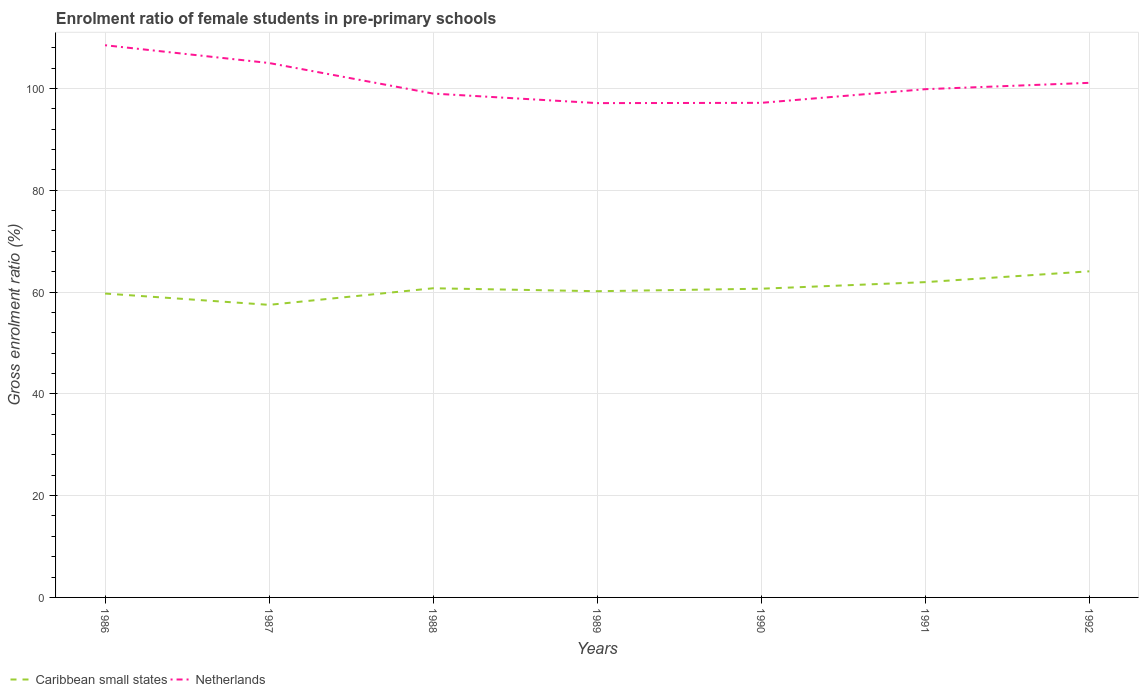How many different coloured lines are there?
Give a very brief answer. 2. Is the number of lines equal to the number of legend labels?
Your answer should be compact. Yes. Across all years, what is the maximum enrolment ratio of female students in pre-primary schools in Netherlands?
Make the answer very short. 97.11. In which year was the enrolment ratio of female students in pre-primary schools in Netherlands maximum?
Offer a very short reply. 1989. What is the total enrolment ratio of female students in pre-primary schools in Netherlands in the graph?
Make the answer very short. 6. What is the difference between the highest and the second highest enrolment ratio of female students in pre-primary schools in Caribbean small states?
Provide a short and direct response. 6.59. What is the difference between the highest and the lowest enrolment ratio of female students in pre-primary schools in Caribbean small states?
Ensure brevity in your answer.  3. Is the enrolment ratio of female students in pre-primary schools in Netherlands strictly greater than the enrolment ratio of female students in pre-primary schools in Caribbean small states over the years?
Make the answer very short. No. How many lines are there?
Provide a succinct answer. 2. How are the legend labels stacked?
Keep it short and to the point. Horizontal. What is the title of the graph?
Ensure brevity in your answer.  Enrolment ratio of female students in pre-primary schools. Does "Uzbekistan" appear as one of the legend labels in the graph?
Offer a terse response. No. What is the label or title of the X-axis?
Offer a very short reply. Years. What is the label or title of the Y-axis?
Your answer should be very brief. Gross enrolment ratio (%). What is the Gross enrolment ratio (%) in Caribbean small states in 1986?
Provide a short and direct response. 59.7. What is the Gross enrolment ratio (%) in Netherlands in 1986?
Offer a very short reply. 108.48. What is the Gross enrolment ratio (%) of Caribbean small states in 1987?
Your answer should be very brief. 57.48. What is the Gross enrolment ratio (%) of Netherlands in 1987?
Offer a very short reply. 104.98. What is the Gross enrolment ratio (%) in Caribbean small states in 1988?
Provide a short and direct response. 60.73. What is the Gross enrolment ratio (%) of Netherlands in 1988?
Your response must be concise. 98.98. What is the Gross enrolment ratio (%) in Caribbean small states in 1989?
Give a very brief answer. 60.16. What is the Gross enrolment ratio (%) in Netherlands in 1989?
Make the answer very short. 97.11. What is the Gross enrolment ratio (%) of Caribbean small states in 1990?
Your answer should be compact. 60.65. What is the Gross enrolment ratio (%) in Netherlands in 1990?
Your answer should be compact. 97.16. What is the Gross enrolment ratio (%) in Caribbean small states in 1991?
Keep it short and to the point. 61.94. What is the Gross enrolment ratio (%) of Netherlands in 1991?
Provide a short and direct response. 99.84. What is the Gross enrolment ratio (%) of Caribbean small states in 1992?
Offer a very short reply. 64.06. What is the Gross enrolment ratio (%) of Netherlands in 1992?
Your response must be concise. 101.09. Across all years, what is the maximum Gross enrolment ratio (%) in Caribbean small states?
Your answer should be compact. 64.06. Across all years, what is the maximum Gross enrolment ratio (%) of Netherlands?
Make the answer very short. 108.48. Across all years, what is the minimum Gross enrolment ratio (%) of Caribbean small states?
Your answer should be very brief. 57.48. Across all years, what is the minimum Gross enrolment ratio (%) in Netherlands?
Ensure brevity in your answer.  97.11. What is the total Gross enrolment ratio (%) of Caribbean small states in the graph?
Offer a very short reply. 424.71. What is the total Gross enrolment ratio (%) of Netherlands in the graph?
Provide a short and direct response. 707.64. What is the difference between the Gross enrolment ratio (%) in Caribbean small states in 1986 and that in 1987?
Provide a succinct answer. 2.22. What is the difference between the Gross enrolment ratio (%) in Netherlands in 1986 and that in 1987?
Make the answer very short. 3.49. What is the difference between the Gross enrolment ratio (%) of Caribbean small states in 1986 and that in 1988?
Give a very brief answer. -1.04. What is the difference between the Gross enrolment ratio (%) of Netherlands in 1986 and that in 1988?
Provide a succinct answer. 9.5. What is the difference between the Gross enrolment ratio (%) in Caribbean small states in 1986 and that in 1989?
Keep it short and to the point. -0.46. What is the difference between the Gross enrolment ratio (%) in Netherlands in 1986 and that in 1989?
Ensure brevity in your answer.  11.37. What is the difference between the Gross enrolment ratio (%) of Caribbean small states in 1986 and that in 1990?
Give a very brief answer. -0.95. What is the difference between the Gross enrolment ratio (%) in Netherlands in 1986 and that in 1990?
Offer a very short reply. 11.32. What is the difference between the Gross enrolment ratio (%) of Caribbean small states in 1986 and that in 1991?
Your response must be concise. -2.24. What is the difference between the Gross enrolment ratio (%) in Netherlands in 1986 and that in 1991?
Make the answer very short. 8.63. What is the difference between the Gross enrolment ratio (%) in Caribbean small states in 1986 and that in 1992?
Your response must be concise. -4.37. What is the difference between the Gross enrolment ratio (%) in Netherlands in 1986 and that in 1992?
Provide a short and direct response. 7.39. What is the difference between the Gross enrolment ratio (%) in Caribbean small states in 1987 and that in 1988?
Provide a short and direct response. -3.26. What is the difference between the Gross enrolment ratio (%) of Netherlands in 1987 and that in 1988?
Provide a short and direct response. 6. What is the difference between the Gross enrolment ratio (%) of Caribbean small states in 1987 and that in 1989?
Ensure brevity in your answer.  -2.68. What is the difference between the Gross enrolment ratio (%) of Netherlands in 1987 and that in 1989?
Your response must be concise. 7.88. What is the difference between the Gross enrolment ratio (%) of Caribbean small states in 1987 and that in 1990?
Make the answer very short. -3.17. What is the difference between the Gross enrolment ratio (%) in Netherlands in 1987 and that in 1990?
Ensure brevity in your answer.  7.83. What is the difference between the Gross enrolment ratio (%) of Caribbean small states in 1987 and that in 1991?
Offer a very short reply. -4.46. What is the difference between the Gross enrolment ratio (%) of Netherlands in 1987 and that in 1991?
Your answer should be very brief. 5.14. What is the difference between the Gross enrolment ratio (%) of Caribbean small states in 1987 and that in 1992?
Keep it short and to the point. -6.59. What is the difference between the Gross enrolment ratio (%) in Netherlands in 1987 and that in 1992?
Offer a very short reply. 3.89. What is the difference between the Gross enrolment ratio (%) in Caribbean small states in 1988 and that in 1989?
Provide a succinct answer. 0.58. What is the difference between the Gross enrolment ratio (%) in Netherlands in 1988 and that in 1989?
Your response must be concise. 1.87. What is the difference between the Gross enrolment ratio (%) of Caribbean small states in 1988 and that in 1990?
Your response must be concise. 0.09. What is the difference between the Gross enrolment ratio (%) in Netherlands in 1988 and that in 1990?
Offer a terse response. 1.82. What is the difference between the Gross enrolment ratio (%) in Caribbean small states in 1988 and that in 1991?
Your response must be concise. -1.2. What is the difference between the Gross enrolment ratio (%) of Netherlands in 1988 and that in 1991?
Make the answer very short. -0.86. What is the difference between the Gross enrolment ratio (%) of Caribbean small states in 1988 and that in 1992?
Ensure brevity in your answer.  -3.33. What is the difference between the Gross enrolment ratio (%) in Netherlands in 1988 and that in 1992?
Your answer should be very brief. -2.11. What is the difference between the Gross enrolment ratio (%) in Caribbean small states in 1989 and that in 1990?
Offer a very short reply. -0.49. What is the difference between the Gross enrolment ratio (%) of Netherlands in 1989 and that in 1990?
Provide a succinct answer. -0.05. What is the difference between the Gross enrolment ratio (%) in Caribbean small states in 1989 and that in 1991?
Your answer should be very brief. -1.78. What is the difference between the Gross enrolment ratio (%) of Netherlands in 1989 and that in 1991?
Give a very brief answer. -2.74. What is the difference between the Gross enrolment ratio (%) in Caribbean small states in 1989 and that in 1992?
Your answer should be compact. -3.91. What is the difference between the Gross enrolment ratio (%) in Netherlands in 1989 and that in 1992?
Your response must be concise. -3.98. What is the difference between the Gross enrolment ratio (%) in Caribbean small states in 1990 and that in 1991?
Make the answer very short. -1.29. What is the difference between the Gross enrolment ratio (%) in Netherlands in 1990 and that in 1991?
Offer a very short reply. -2.69. What is the difference between the Gross enrolment ratio (%) in Caribbean small states in 1990 and that in 1992?
Make the answer very short. -3.42. What is the difference between the Gross enrolment ratio (%) in Netherlands in 1990 and that in 1992?
Give a very brief answer. -3.93. What is the difference between the Gross enrolment ratio (%) in Caribbean small states in 1991 and that in 1992?
Give a very brief answer. -2.13. What is the difference between the Gross enrolment ratio (%) in Netherlands in 1991 and that in 1992?
Make the answer very short. -1.25. What is the difference between the Gross enrolment ratio (%) in Caribbean small states in 1986 and the Gross enrolment ratio (%) in Netherlands in 1987?
Offer a very short reply. -45.28. What is the difference between the Gross enrolment ratio (%) in Caribbean small states in 1986 and the Gross enrolment ratio (%) in Netherlands in 1988?
Provide a short and direct response. -39.28. What is the difference between the Gross enrolment ratio (%) of Caribbean small states in 1986 and the Gross enrolment ratio (%) of Netherlands in 1989?
Provide a succinct answer. -37.41. What is the difference between the Gross enrolment ratio (%) of Caribbean small states in 1986 and the Gross enrolment ratio (%) of Netherlands in 1990?
Give a very brief answer. -37.46. What is the difference between the Gross enrolment ratio (%) of Caribbean small states in 1986 and the Gross enrolment ratio (%) of Netherlands in 1991?
Your answer should be very brief. -40.15. What is the difference between the Gross enrolment ratio (%) of Caribbean small states in 1986 and the Gross enrolment ratio (%) of Netherlands in 1992?
Keep it short and to the point. -41.39. What is the difference between the Gross enrolment ratio (%) of Caribbean small states in 1987 and the Gross enrolment ratio (%) of Netherlands in 1988?
Your answer should be compact. -41.5. What is the difference between the Gross enrolment ratio (%) in Caribbean small states in 1987 and the Gross enrolment ratio (%) in Netherlands in 1989?
Offer a very short reply. -39.63. What is the difference between the Gross enrolment ratio (%) in Caribbean small states in 1987 and the Gross enrolment ratio (%) in Netherlands in 1990?
Offer a very short reply. -39.68. What is the difference between the Gross enrolment ratio (%) in Caribbean small states in 1987 and the Gross enrolment ratio (%) in Netherlands in 1991?
Your response must be concise. -42.37. What is the difference between the Gross enrolment ratio (%) in Caribbean small states in 1987 and the Gross enrolment ratio (%) in Netherlands in 1992?
Provide a short and direct response. -43.61. What is the difference between the Gross enrolment ratio (%) of Caribbean small states in 1988 and the Gross enrolment ratio (%) of Netherlands in 1989?
Provide a short and direct response. -36.37. What is the difference between the Gross enrolment ratio (%) in Caribbean small states in 1988 and the Gross enrolment ratio (%) in Netherlands in 1990?
Keep it short and to the point. -36.42. What is the difference between the Gross enrolment ratio (%) of Caribbean small states in 1988 and the Gross enrolment ratio (%) of Netherlands in 1991?
Give a very brief answer. -39.11. What is the difference between the Gross enrolment ratio (%) of Caribbean small states in 1988 and the Gross enrolment ratio (%) of Netherlands in 1992?
Your answer should be compact. -40.35. What is the difference between the Gross enrolment ratio (%) in Caribbean small states in 1989 and the Gross enrolment ratio (%) in Netherlands in 1990?
Provide a short and direct response. -37. What is the difference between the Gross enrolment ratio (%) in Caribbean small states in 1989 and the Gross enrolment ratio (%) in Netherlands in 1991?
Your response must be concise. -39.69. What is the difference between the Gross enrolment ratio (%) of Caribbean small states in 1989 and the Gross enrolment ratio (%) of Netherlands in 1992?
Offer a very short reply. -40.93. What is the difference between the Gross enrolment ratio (%) of Caribbean small states in 1990 and the Gross enrolment ratio (%) of Netherlands in 1991?
Offer a terse response. -39.2. What is the difference between the Gross enrolment ratio (%) in Caribbean small states in 1990 and the Gross enrolment ratio (%) in Netherlands in 1992?
Your answer should be very brief. -40.44. What is the difference between the Gross enrolment ratio (%) in Caribbean small states in 1991 and the Gross enrolment ratio (%) in Netherlands in 1992?
Offer a terse response. -39.15. What is the average Gross enrolment ratio (%) in Caribbean small states per year?
Offer a terse response. 60.67. What is the average Gross enrolment ratio (%) in Netherlands per year?
Provide a short and direct response. 101.09. In the year 1986, what is the difference between the Gross enrolment ratio (%) of Caribbean small states and Gross enrolment ratio (%) of Netherlands?
Offer a very short reply. -48.78. In the year 1987, what is the difference between the Gross enrolment ratio (%) in Caribbean small states and Gross enrolment ratio (%) in Netherlands?
Give a very brief answer. -47.51. In the year 1988, what is the difference between the Gross enrolment ratio (%) of Caribbean small states and Gross enrolment ratio (%) of Netherlands?
Offer a terse response. -38.25. In the year 1989, what is the difference between the Gross enrolment ratio (%) in Caribbean small states and Gross enrolment ratio (%) in Netherlands?
Offer a terse response. -36.95. In the year 1990, what is the difference between the Gross enrolment ratio (%) of Caribbean small states and Gross enrolment ratio (%) of Netherlands?
Your response must be concise. -36.51. In the year 1991, what is the difference between the Gross enrolment ratio (%) of Caribbean small states and Gross enrolment ratio (%) of Netherlands?
Offer a very short reply. -37.91. In the year 1992, what is the difference between the Gross enrolment ratio (%) of Caribbean small states and Gross enrolment ratio (%) of Netherlands?
Give a very brief answer. -37.03. What is the ratio of the Gross enrolment ratio (%) of Caribbean small states in 1986 to that in 1987?
Offer a very short reply. 1.04. What is the ratio of the Gross enrolment ratio (%) of Caribbean small states in 1986 to that in 1988?
Ensure brevity in your answer.  0.98. What is the ratio of the Gross enrolment ratio (%) in Netherlands in 1986 to that in 1988?
Offer a very short reply. 1.1. What is the ratio of the Gross enrolment ratio (%) in Caribbean small states in 1986 to that in 1989?
Your answer should be compact. 0.99. What is the ratio of the Gross enrolment ratio (%) of Netherlands in 1986 to that in 1989?
Your response must be concise. 1.12. What is the ratio of the Gross enrolment ratio (%) of Caribbean small states in 1986 to that in 1990?
Offer a very short reply. 0.98. What is the ratio of the Gross enrolment ratio (%) in Netherlands in 1986 to that in 1990?
Provide a short and direct response. 1.12. What is the ratio of the Gross enrolment ratio (%) of Caribbean small states in 1986 to that in 1991?
Provide a short and direct response. 0.96. What is the ratio of the Gross enrolment ratio (%) of Netherlands in 1986 to that in 1991?
Provide a succinct answer. 1.09. What is the ratio of the Gross enrolment ratio (%) in Caribbean small states in 1986 to that in 1992?
Give a very brief answer. 0.93. What is the ratio of the Gross enrolment ratio (%) in Netherlands in 1986 to that in 1992?
Keep it short and to the point. 1.07. What is the ratio of the Gross enrolment ratio (%) of Caribbean small states in 1987 to that in 1988?
Make the answer very short. 0.95. What is the ratio of the Gross enrolment ratio (%) in Netherlands in 1987 to that in 1988?
Your answer should be very brief. 1.06. What is the ratio of the Gross enrolment ratio (%) in Caribbean small states in 1987 to that in 1989?
Your answer should be compact. 0.96. What is the ratio of the Gross enrolment ratio (%) of Netherlands in 1987 to that in 1989?
Offer a terse response. 1.08. What is the ratio of the Gross enrolment ratio (%) in Caribbean small states in 1987 to that in 1990?
Offer a very short reply. 0.95. What is the ratio of the Gross enrolment ratio (%) in Netherlands in 1987 to that in 1990?
Make the answer very short. 1.08. What is the ratio of the Gross enrolment ratio (%) in Caribbean small states in 1987 to that in 1991?
Provide a succinct answer. 0.93. What is the ratio of the Gross enrolment ratio (%) in Netherlands in 1987 to that in 1991?
Keep it short and to the point. 1.05. What is the ratio of the Gross enrolment ratio (%) of Caribbean small states in 1987 to that in 1992?
Ensure brevity in your answer.  0.9. What is the ratio of the Gross enrolment ratio (%) in Caribbean small states in 1988 to that in 1989?
Your response must be concise. 1.01. What is the ratio of the Gross enrolment ratio (%) of Netherlands in 1988 to that in 1989?
Provide a succinct answer. 1.02. What is the ratio of the Gross enrolment ratio (%) of Netherlands in 1988 to that in 1990?
Your answer should be very brief. 1.02. What is the ratio of the Gross enrolment ratio (%) in Caribbean small states in 1988 to that in 1991?
Offer a very short reply. 0.98. What is the ratio of the Gross enrolment ratio (%) in Caribbean small states in 1988 to that in 1992?
Your response must be concise. 0.95. What is the ratio of the Gross enrolment ratio (%) in Netherlands in 1988 to that in 1992?
Ensure brevity in your answer.  0.98. What is the ratio of the Gross enrolment ratio (%) in Caribbean small states in 1989 to that in 1991?
Your response must be concise. 0.97. What is the ratio of the Gross enrolment ratio (%) in Netherlands in 1989 to that in 1991?
Your response must be concise. 0.97. What is the ratio of the Gross enrolment ratio (%) of Caribbean small states in 1989 to that in 1992?
Make the answer very short. 0.94. What is the ratio of the Gross enrolment ratio (%) in Netherlands in 1989 to that in 1992?
Your answer should be compact. 0.96. What is the ratio of the Gross enrolment ratio (%) in Caribbean small states in 1990 to that in 1991?
Offer a very short reply. 0.98. What is the ratio of the Gross enrolment ratio (%) of Netherlands in 1990 to that in 1991?
Your answer should be very brief. 0.97. What is the ratio of the Gross enrolment ratio (%) of Caribbean small states in 1990 to that in 1992?
Your answer should be compact. 0.95. What is the ratio of the Gross enrolment ratio (%) in Netherlands in 1990 to that in 1992?
Offer a terse response. 0.96. What is the ratio of the Gross enrolment ratio (%) in Caribbean small states in 1991 to that in 1992?
Keep it short and to the point. 0.97. What is the difference between the highest and the second highest Gross enrolment ratio (%) in Caribbean small states?
Provide a short and direct response. 2.13. What is the difference between the highest and the second highest Gross enrolment ratio (%) of Netherlands?
Make the answer very short. 3.49. What is the difference between the highest and the lowest Gross enrolment ratio (%) of Caribbean small states?
Offer a very short reply. 6.59. What is the difference between the highest and the lowest Gross enrolment ratio (%) in Netherlands?
Provide a succinct answer. 11.37. 